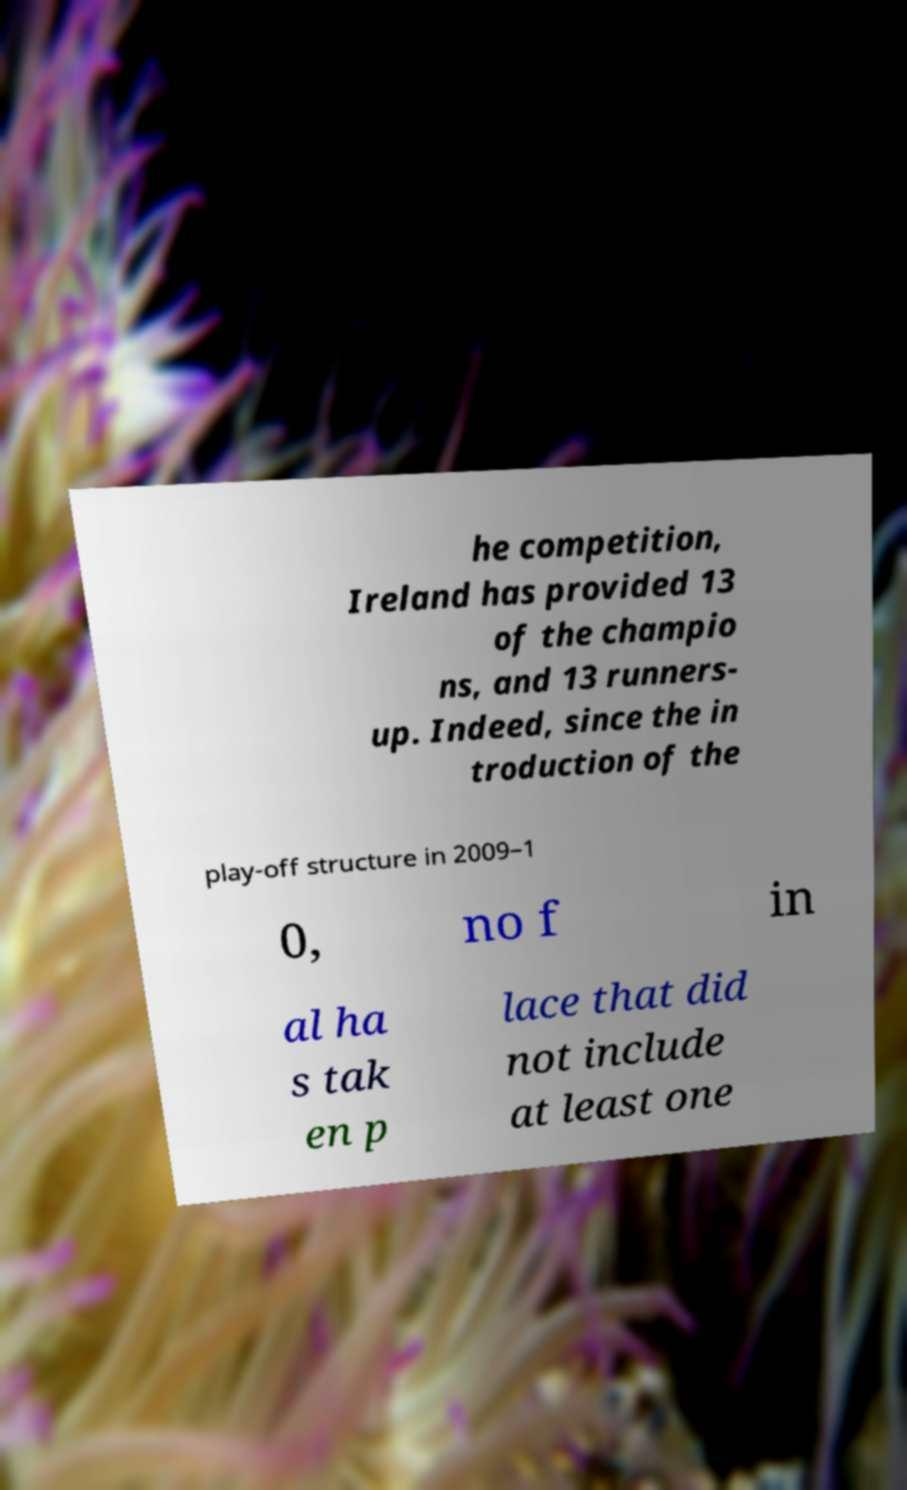Please read and relay the text visible in this image. What does it say? he competition, Ireland has provided 13 of the champio ns, and 13 runners- up. Indeed, since the in troduction of the play-off structure in 2009–1 0, no f in al ha s tak en p lace that did not include at least one 